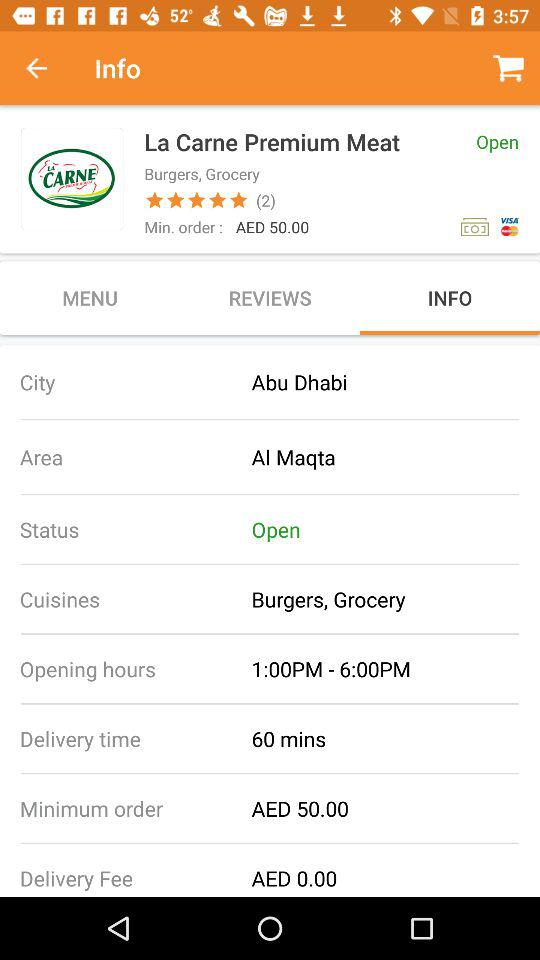What is the minimum order for La Carne Premium Meat?
Answer the question using a single word or phrase. AED 50.00 